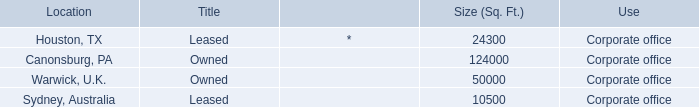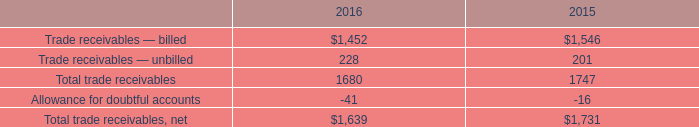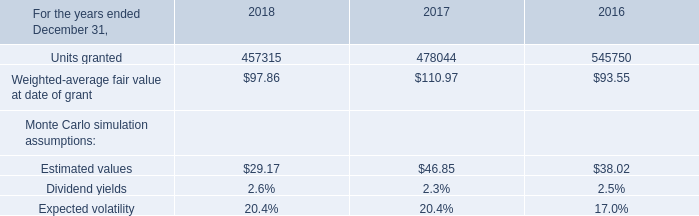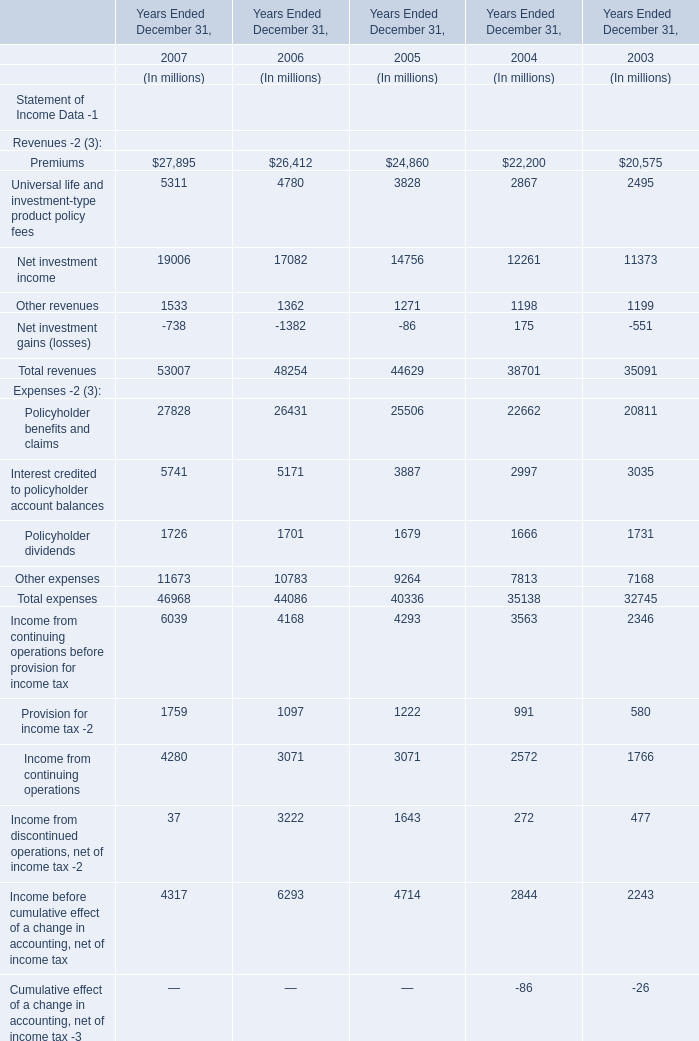What is the increasing rate of Net income between 2005 Ended December 31 and 2006 Ended December 31? 
Computations: ((6293 - 4714) / 4714)
Answer: 0.33496. 